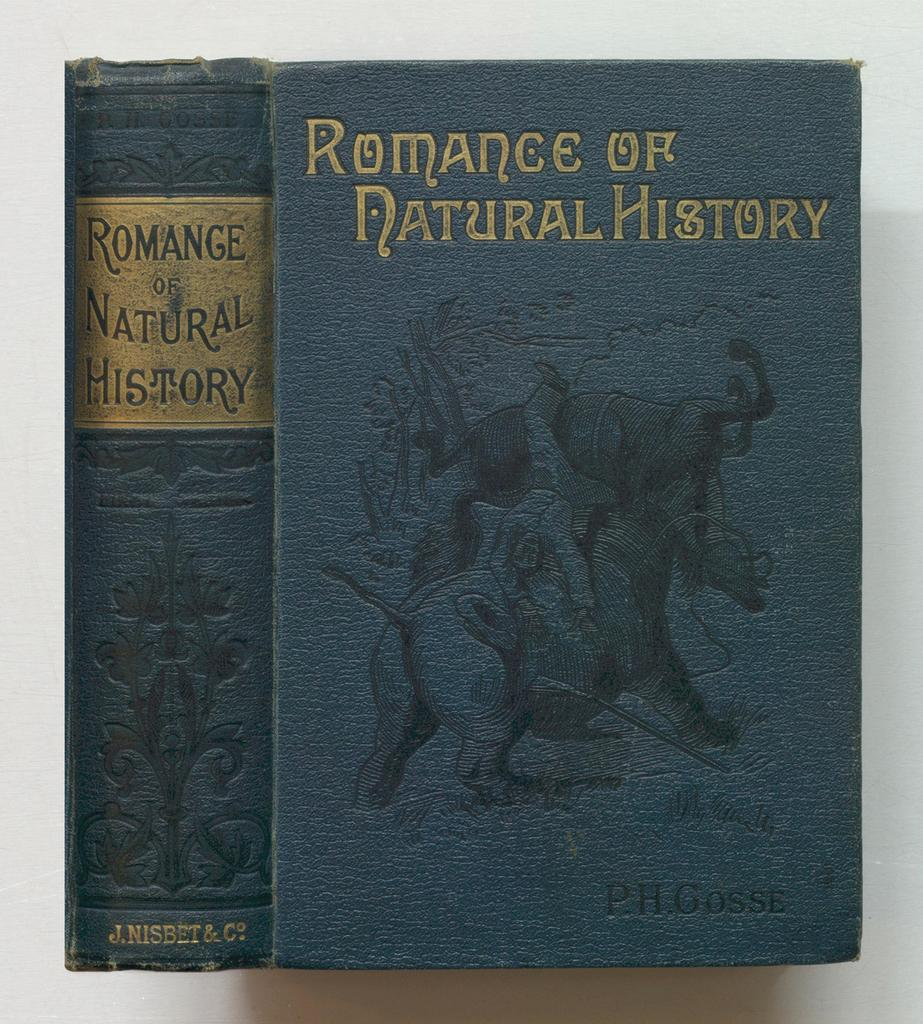<image>
Relay a brief, clear account of the picture shown. Two book volumes with the title Romance of Natural History. 